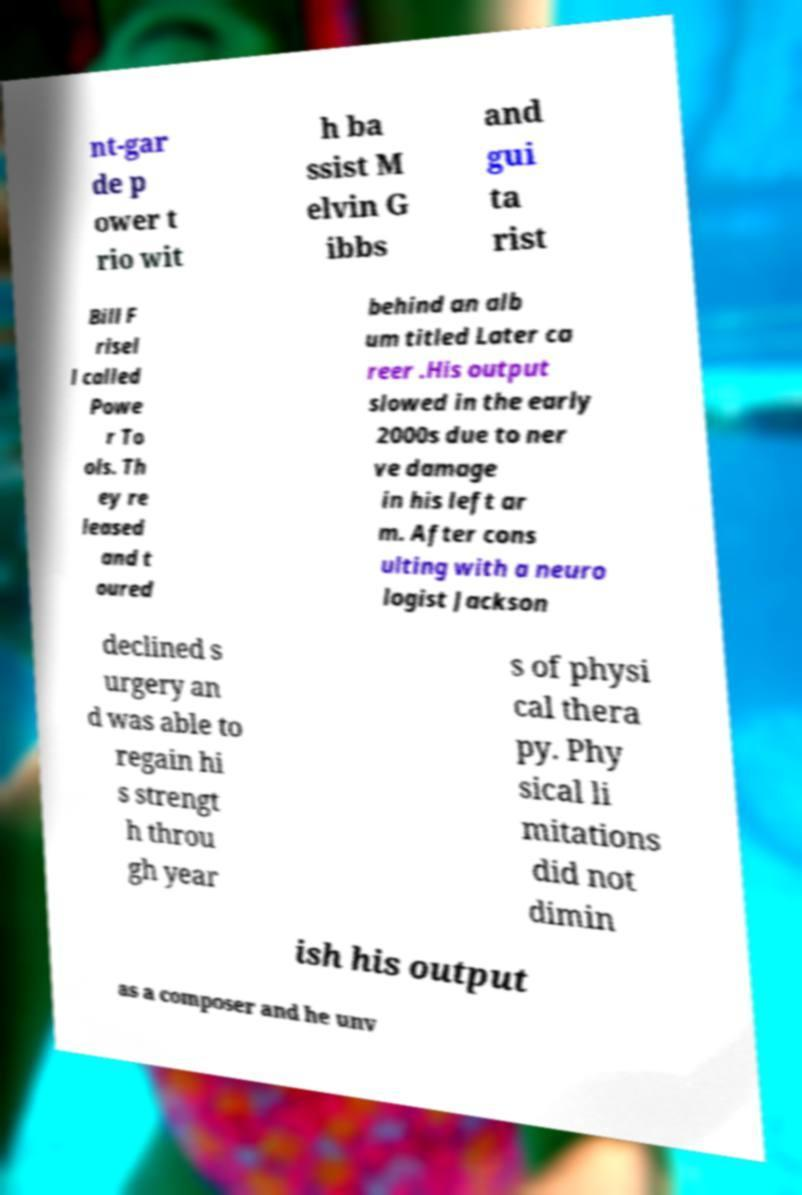There's text embedded in this image that I need extracted. Can you transcribe it verbatim? nt-gar de p ower t rio wit h ba ssist M elvin G ibbs and gui ta rist Bill F risel l called Powe r To ols. Th ey re leased and t oured behind an alb um titled Later ca reer .His output slowed in the early 2000s due to ner ve damage in his left ar m. After cons ulting with a neuro logist Jackson declined s urgery an d was able to regain hi s strengt h throu gh year s of physi cal thera py. Phy sical li mitations did not dimin ish his output as a composer and he unv 